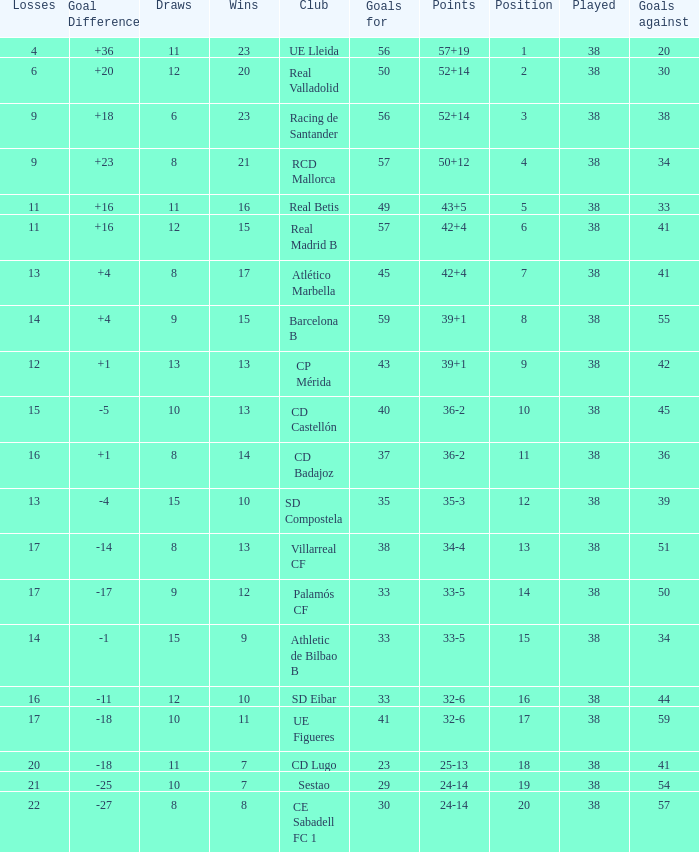What is the highest number of loss with a 7 position and more than 45 goals? None. 